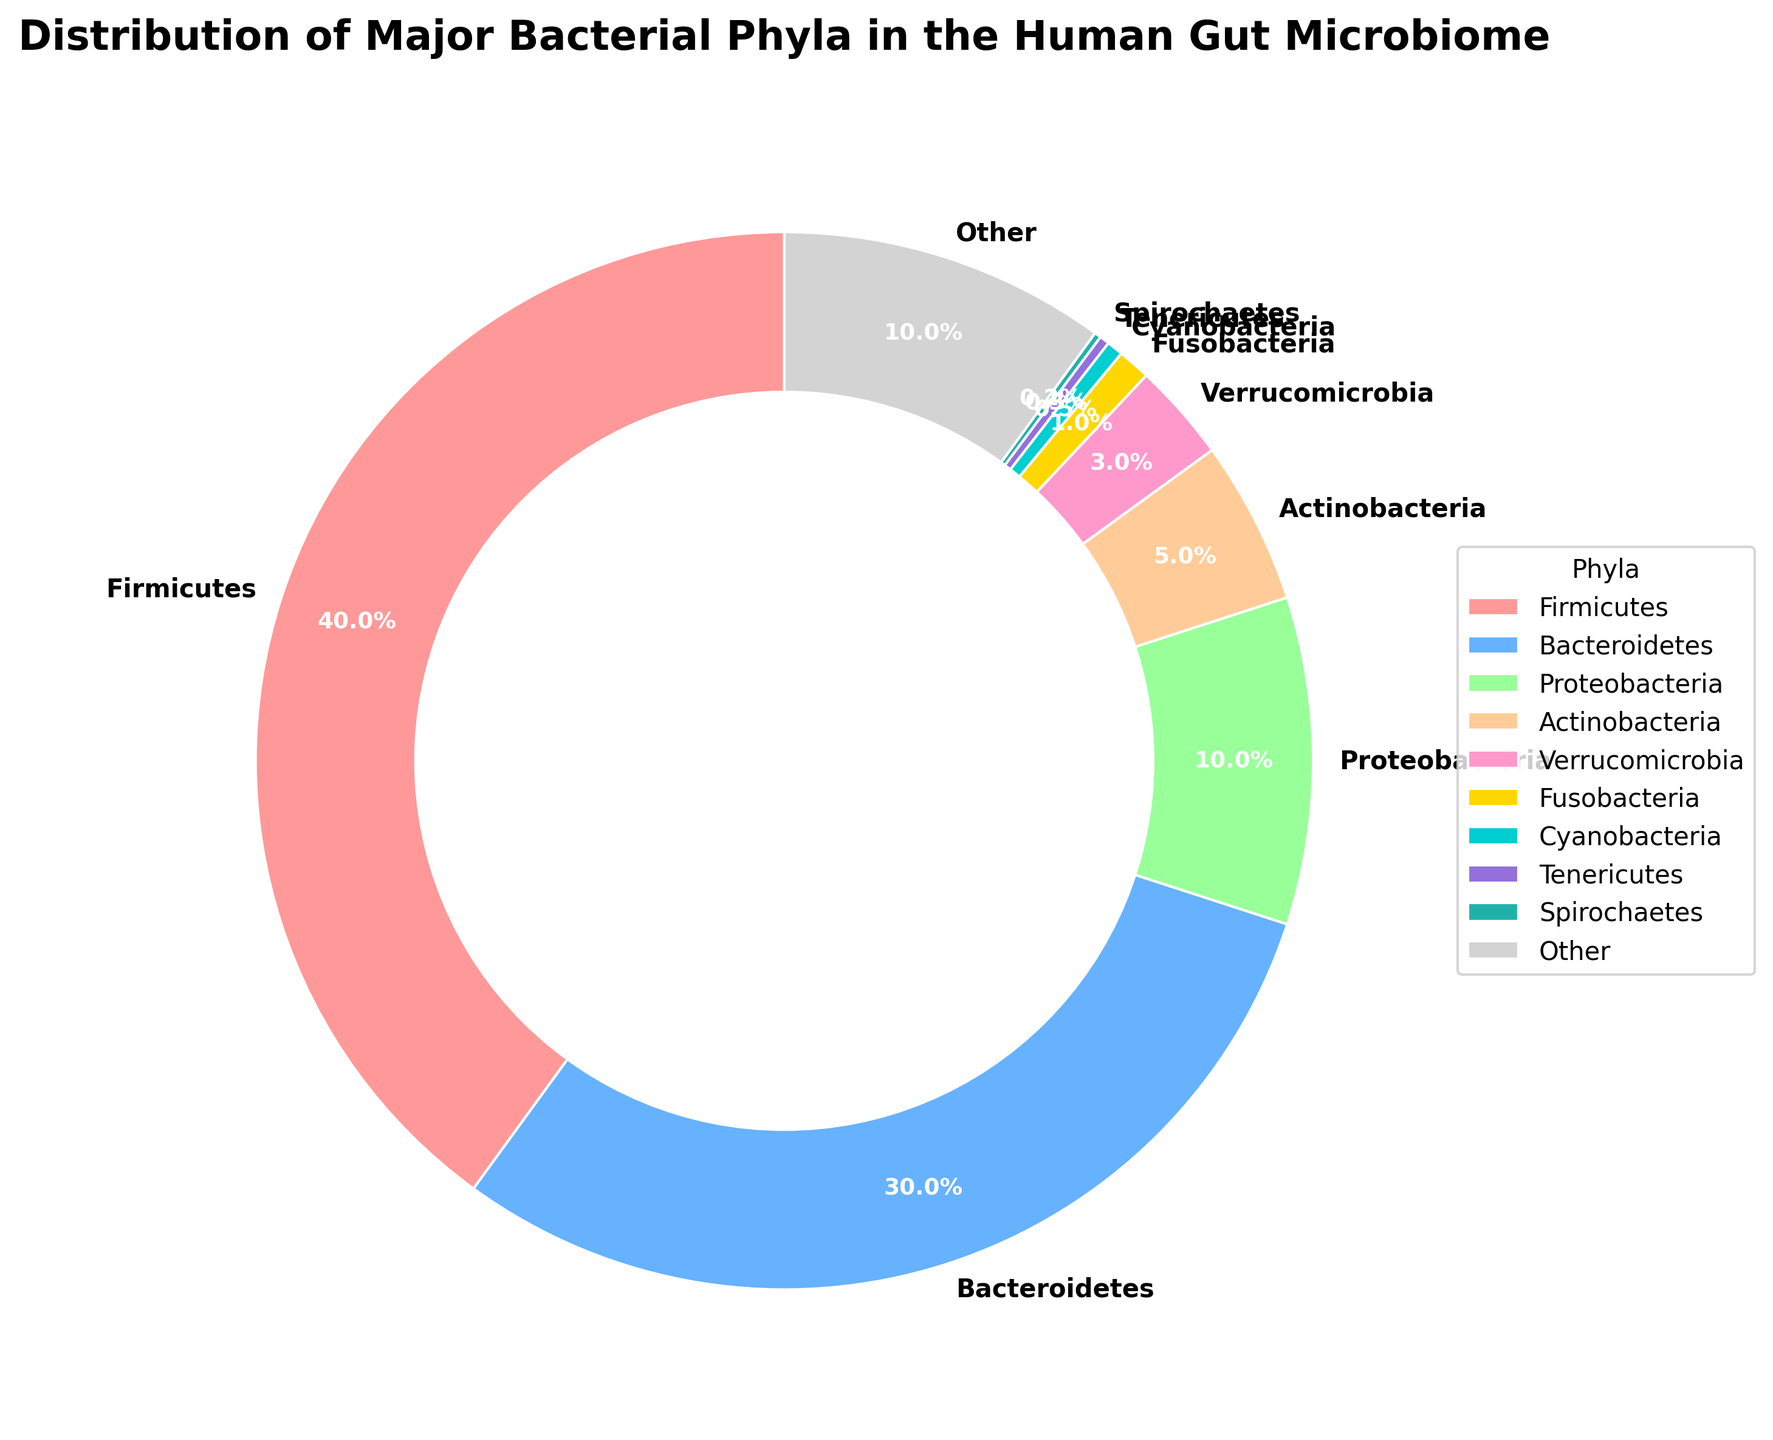What percentage of the gut microbiome is made up of Firmicutes and Bacteroidetes combined? First, note the percentages for Firmicutes (40%) and Bacteroidetes (30%). Add these values together: 40% + 30% = 70%.
Answer: 70% Which bacterial phylum constitutes a smaller portion of the gut microbiome, Verrucomicrobia or Fusobacteria? Verrucomicrobia has a percentage of 3%, while Fusobacteria is at 1%. Comparing these values, Verrucomicrobia is larger than Fusobacteria.
Answer: Fusobacteria What is the total percentage of the "Other" category combined with Cyanobacteria, Tenericutes, and Spirochaetes? Identify the percentages for "Other" (10%), Cyanobacteria (0.5%), Tenericutes (0.3%), and Spirochaetes (0.2%). Add these figures: 10% + 0.5% + 0.3% + 0.2% = 11.0%.
Answer: 11.0% Which phylum has the second-highest representation in the human gut microbiome? According to the chart, Firmicutes is the highest at 40%, followed by Bacteroidetes at 30%. Therefore, Bacteroidetes is the second-highest.
Answer: Bacteroidetes Visually, which phylum is shown in yellow on the pie chart? By referring to the color legend, identify that the "FFD700" hex color corresponds to yellow. In this case, it represents Verrucomicrobia.
Answer: Verrucomicrobia Are Proteobacteria more or less represented in the gut microbiome compared to Actinobacteria? Proteobacteria have a percentage of 10%, whereas Actinobacteria have 5%. Comparing these values reveals that Proteobacteria are more represented.
Answer: More Do Bacteroidetes and Firmicutes together comprise more than half of the gut microbiome? Summing their percentages, 40% (Firmicutes) + 30% (Bacteroidetes) = 70%. Since 70% is more than 50%, they indeed comprise more than half.
Answer: Yes Based on the visual features, how do the sizes of the wedges for Proteobacteria and Actinobacteria compare? Proteobacteria's wedge is larger because it represents 10% while Actinobacteria's represents 5%. This visual distinction indicates Proteobacteria's wedge is bigger.
Answer: Proteobacteria's wedge is larger What is the combined percentage of the three smallest bacterial phyla depicted in the pie chart? Identify Cyanobacteria at 0.5%, Tenericutes at 0.3%, and Spirochaetes at 0.2%. Adding these values: 0.5% + 0.3% + 0.2% = 1.0%.
Answer: 1.0% Which phylum’s representation in the gut microbiome is approximately one-tenth that of Firmicutes? Firmicutes makes up 40%, so one-tenth of this is 4%. The closest phylum in the chart to this value is Actinobacteria at 5%.
Answer: Actinobacteria 